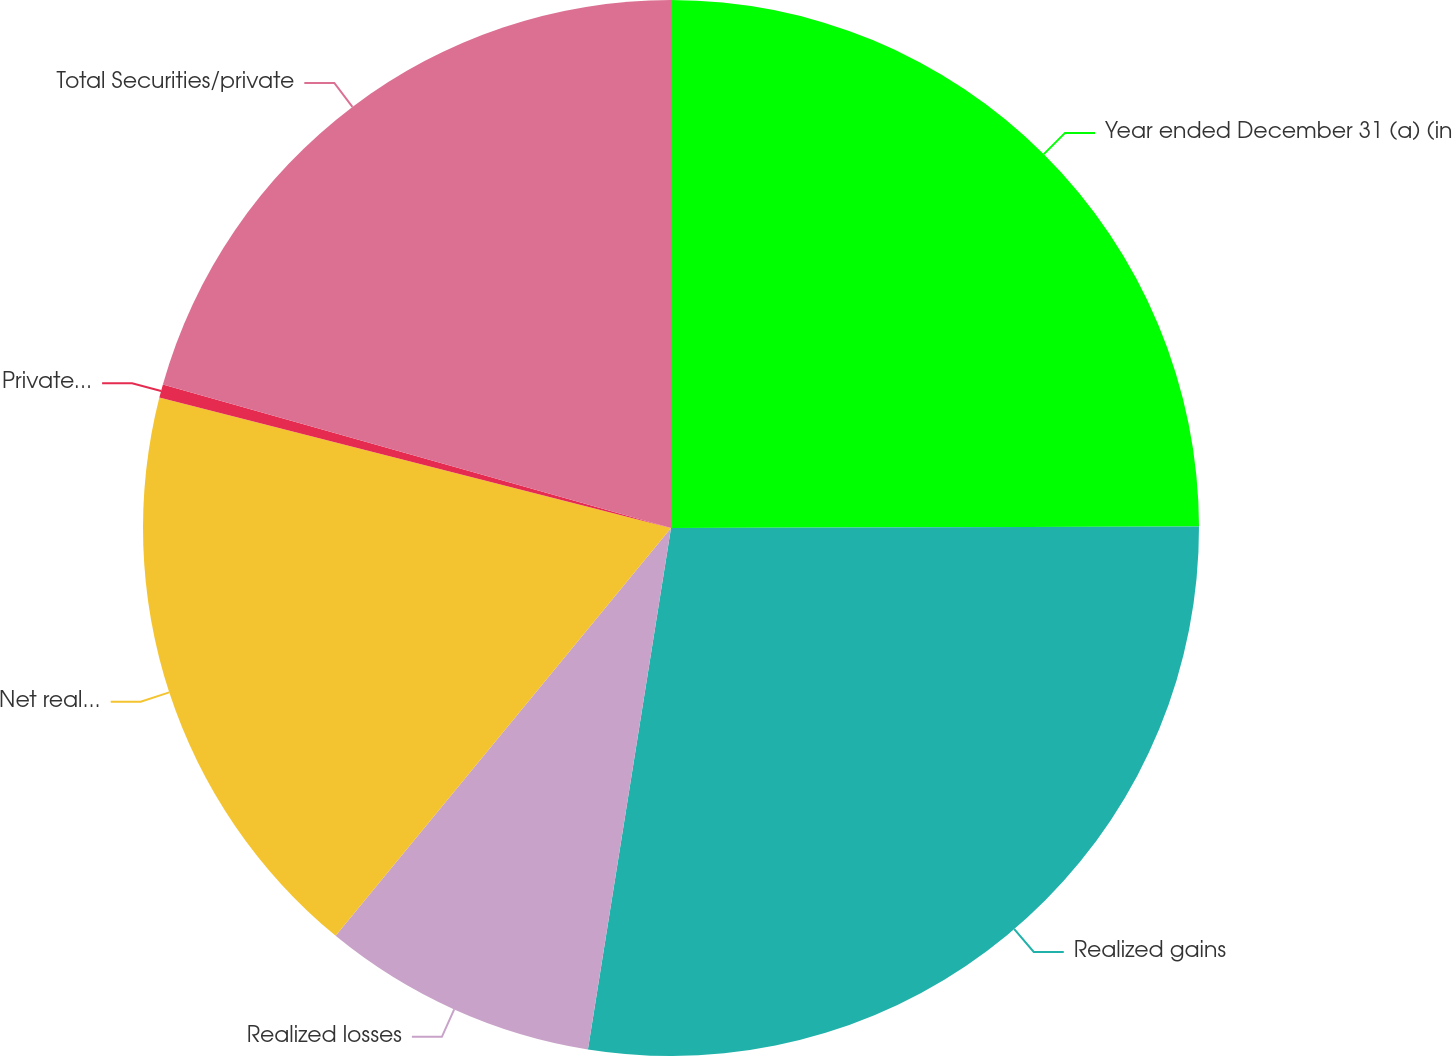Convert chart. <chart><loc_0><loc_0><loc_500><loc_500><pie_chart><fcel>Year ended December 31 (a) (in<fcel>Realized gains<fcel>Realized losses<fcel>Net realized securities gains<fcel>Private equity gains<fcel>Total Securities/private<nl><fcel>24.96%<fcel>27.56%<fcel>8.44%<fcel>18.02%<fcel>0.41%<fcel>20.62%<nl></chart> 